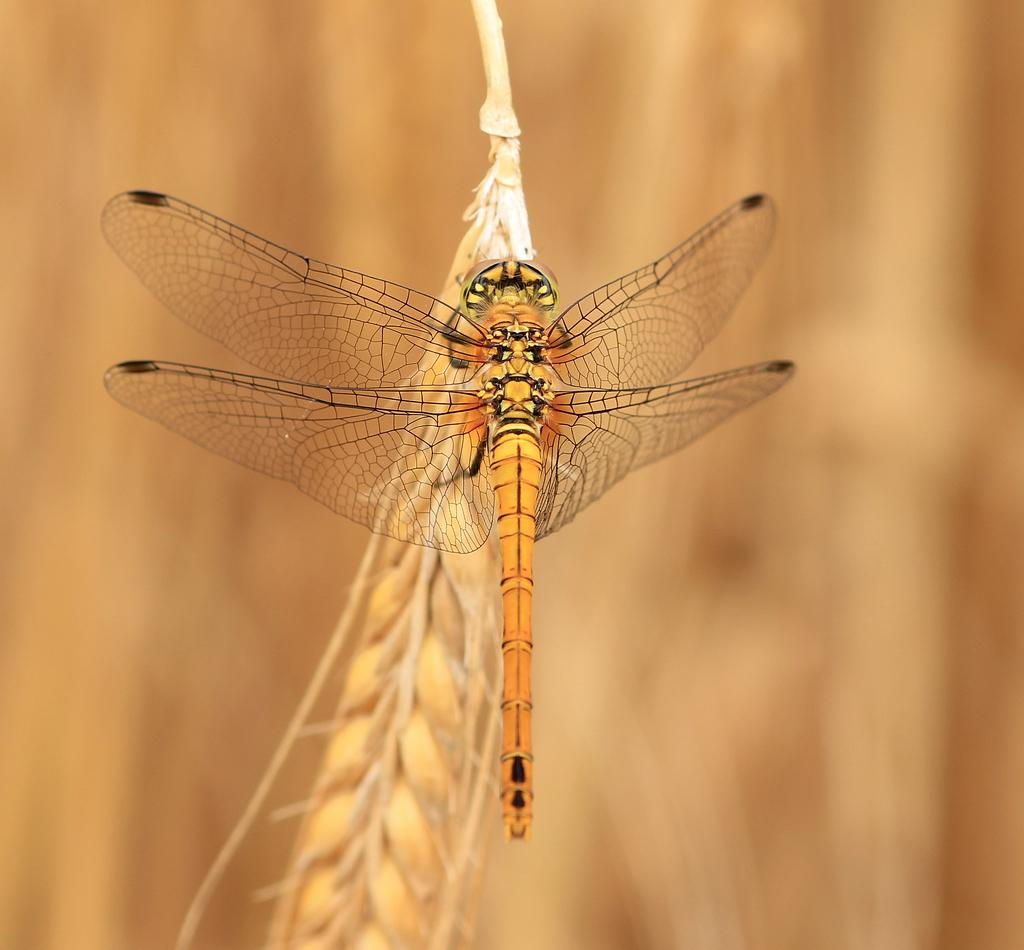What type of creature can be seen in the image? There is an insect in the image. Where is the insect located? The insect is on a wheat plant. Can you describe the background of the image? The background of the image is blurred. What is the value of the bushes in the image? There are no bushes present in the image, so it is not possible to determine their value. 